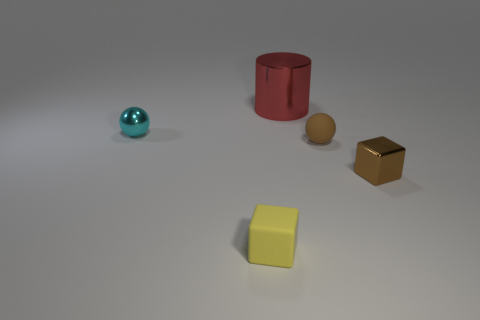Are there any tiny yellow metal objects that have the same shape as the brown rubber thing? no 